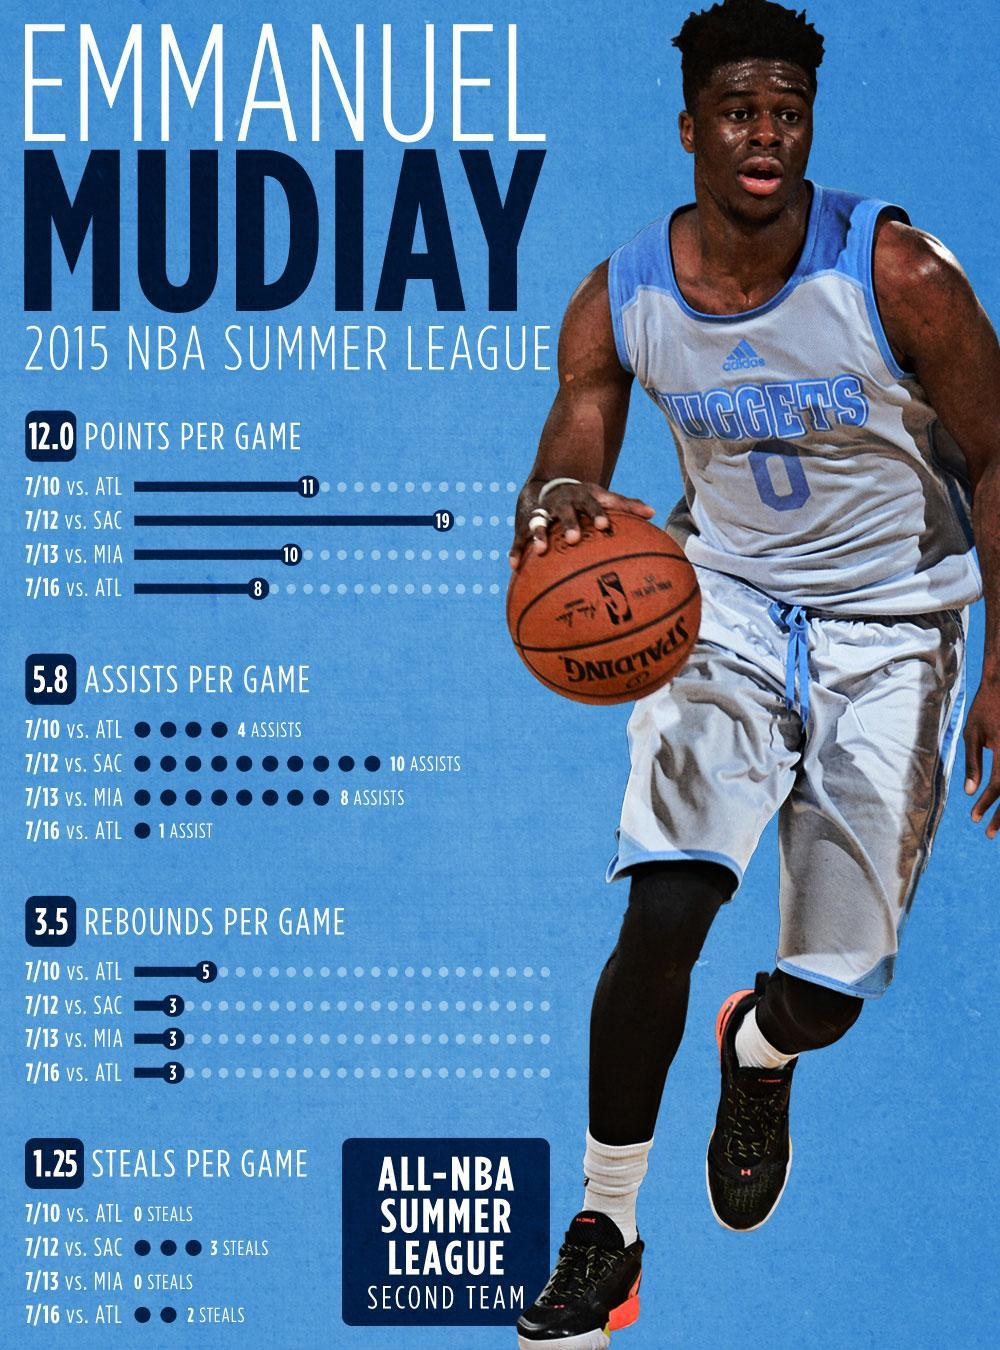What is the total number of rebounds per game from Emmanuel Mudiay?
Answer the question with a short phrase. 14 What is the total number of assists per game from Emmanuel Mudiay? 23 What is the total number of points per game from Emmanuel Mudiay? 48 What is the total number of steals per game from Emmanuel Mudiay? 5 